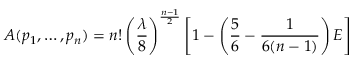Convert formula to latex. <formula><loc_0><loc_0><loc_500><loc_500>A ( p _ { 1 } , \dots , p _ { n } ) = n ! \left ( { \frac { \lambda } { 8 } } \right ) ^ { \frac { n - 1 } { 2 } } \left [ 1 - \left ( { \frac { 5 } { 6 } } - { \frac { 1 } { 6 ( n - 1 ) } } \right ) E \right ]</formula> 